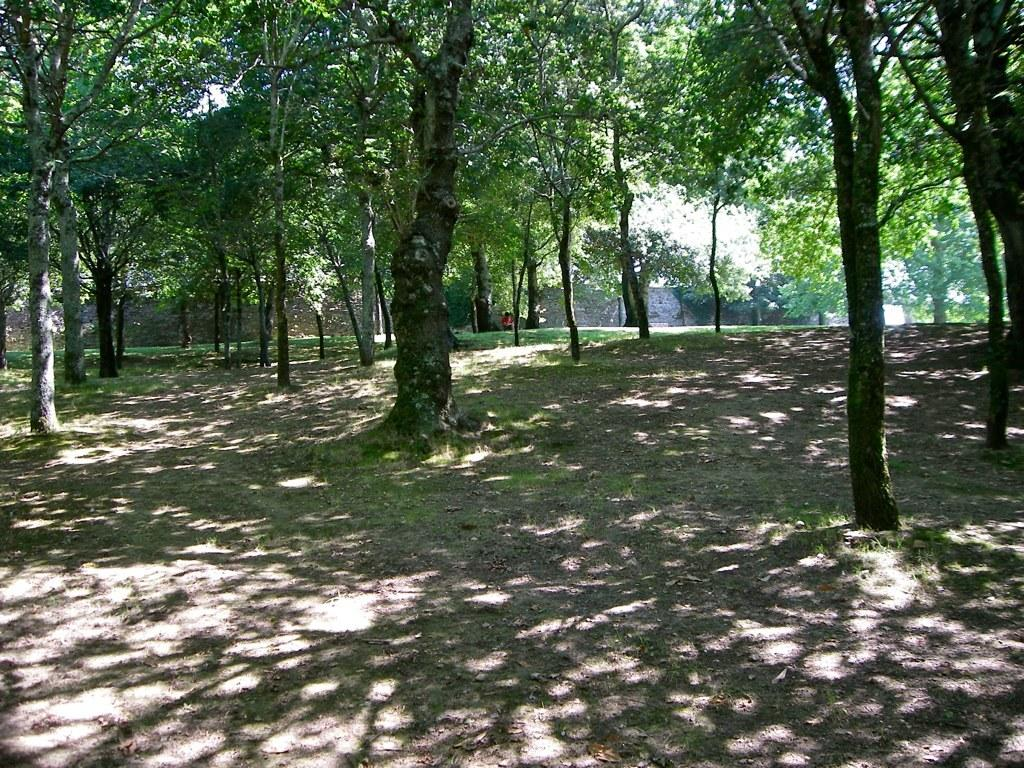What type of vegetation is present in the image? There are many trees, plants, and grass in the image. Can you describe the person in the image? There is a person standing near a wall in the background of the image. What is visible in the background of the image? The sky is visible in the background of the image. What type of wood is the person using to clear their throat in the image? There is no person using wood to clear their throat in the image. 